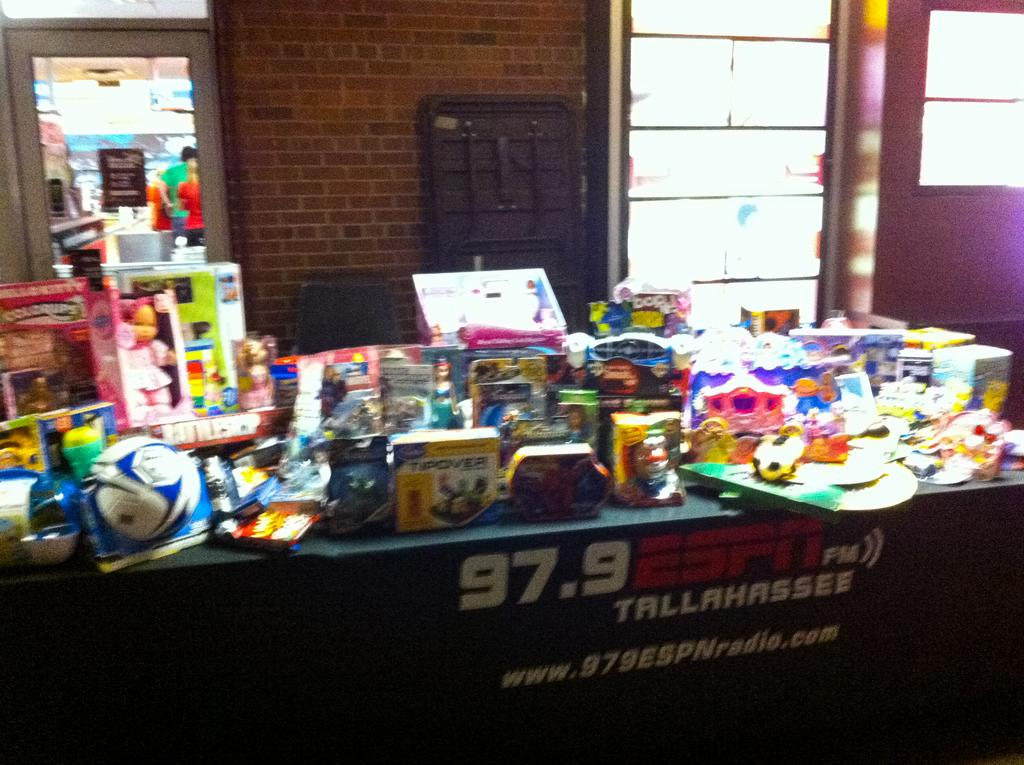<image>
Describe the image concisely. a prize give away from 97.9 ESPN Tallahassee 